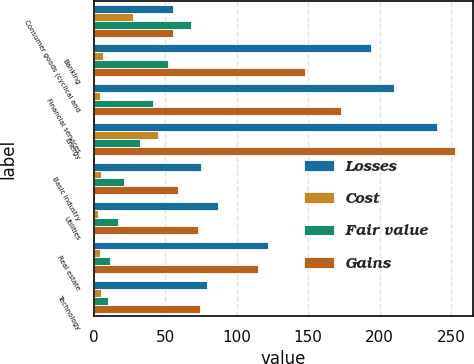<chart> <loc_0><loc_0><loc_500><loc_500><stacked_bar_chart><ecel><fcel>Consumer goods (cyclical and<fcel>Banking<fcel>Financial services<fcel>Energy<fcel>Basic industry<fcel>Utilities<fcel>Real estate<fcel>Technology<nl><fcel>Losses<fcel>55.5<fcel>194<fcel>210<fcel>240<fcel>75<fcel>87<fcel>122<fcel>79<nl><fcel>Cost<fcel>27<fcel>6<fcel>4<fcel>45<fcel>5<fcel>3<fcel>4<fcel>5<nl><fcel>Fair value<fcel>68<fcel>52<fcel>41<fcel>32<fcel>21<fcel>17<fcel>11<fcel>10<nl><fcel>Gains<fcel>55.5<fcel>148<fcel>173<fcel>253<fcel>59<fcel>73<fcel>115<fcel>74<nl></chart> 